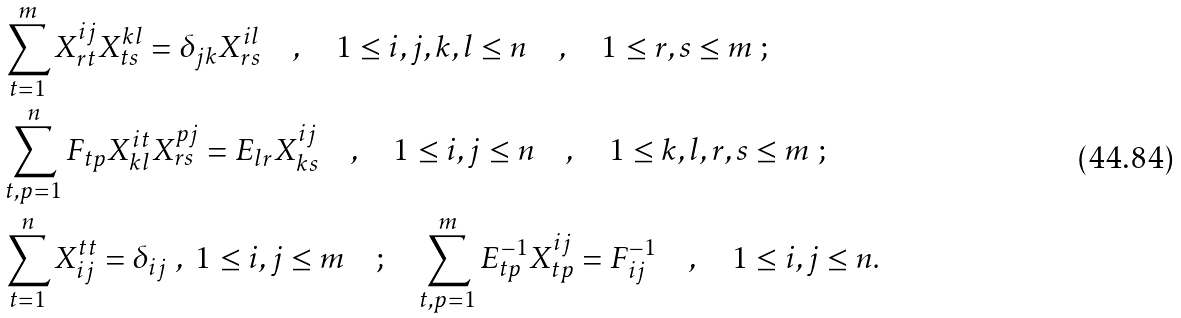Convert formula to latex. <formula><loc_0><loc_0><loc_500><loc_500>& \sum _ { t = 1 } ^ { m } X _ { r t } ^ { i j } X _ { t s } ^ { k l } = \delta _ { j k } X _ { r s } ^ { i l } \quad , \quad 1 \leq i , j , k , l \leq n \quad , \quad 1 \leq r , s \leq m \ ; \\ & \sum _ { t , p = 1 } ^ { n } F _ { t p } X _ { k l } ^ { i t } X _ { r s } ^ { p j } = E _ { l r } X _ { k s } ^ { i j } \quad , \quad 1 \leq i , j \leq n \quad , \quad 1 \leq k , l , r , s \leq m \ ; \\ & \sum _ { t = 1 } ^ { n } X _ { i j } ^ { t t } = \delta _ { i j } \ , \ 1 \leq i , j \leq m \quad ; \quad \sum _ { t , p = 1 } ^ { m } E _ { t p } ^ { - 1 } X _ { t p } ^ { i j } = F _ { i j } ^ { - 1 } \quad , \quad 1 \leq i , j \leq n .</formula> 